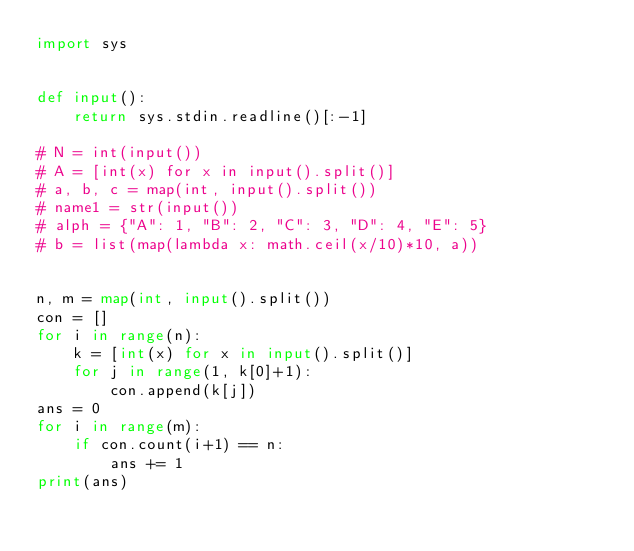<code> <loc_0><loc_0><loc_500><loc_500><_Python_>import sys


def input():
    return sys.stdin.readline()[:-1]

# N = int(input())
# A = [int(x) for x in input().split()]
# a, b, c = map(int, input().split())
# name1 = str(input())
# alph = {"A": 1, "B": 2, "C": 3, "D": 4, "E": 5}
# b = list(map(lambda x: math.ceil(x/10)*10, a))


n, m = map(int, input().split())
con = []
for i in range(n):
    k = [int(x) for x in input().split()]
    for j in range(1, k[0]+1):
        con.append(k[j])
ans = 0
for i in range(m):
    if con.count(i+1) == n:
        ans += 1
print(ans)
</code> 